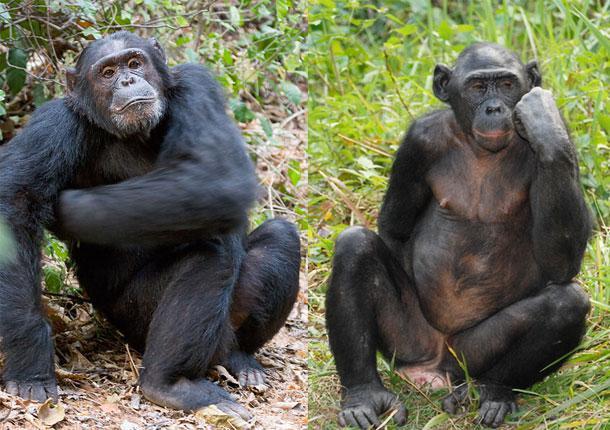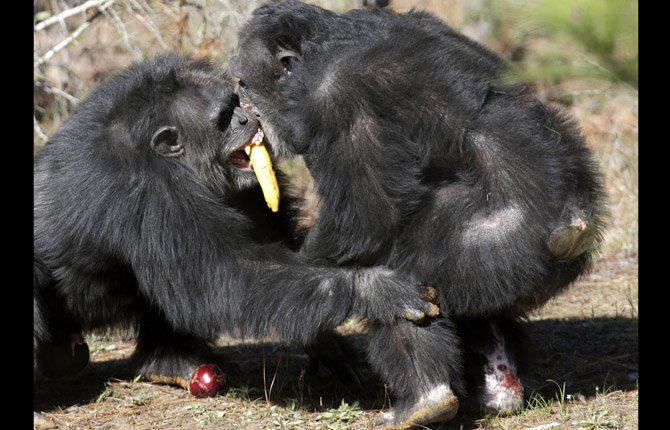The first image is the image on the left, the second image is the image on the right. Evaluate the accuracy of this statement regarding the images: "None of the images has more than two chimpanzees present.". Is it true? Answer yes or no. Yes. The first image is the image on the left, the second image is the image on the right. Evaluate the accuracy of this statement regarding the images: "The image on the right contains two chimpanzees.". Is it true? Answer yes or no. Yes. 